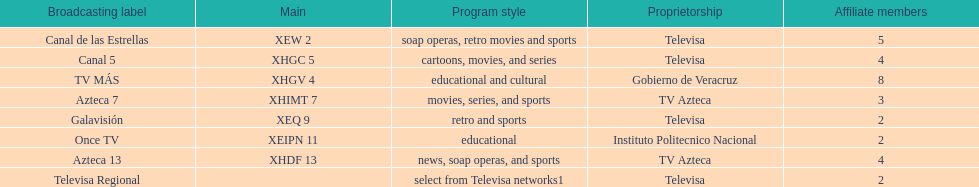How many networks have more affiliates than canal de las estrellas? 1. 